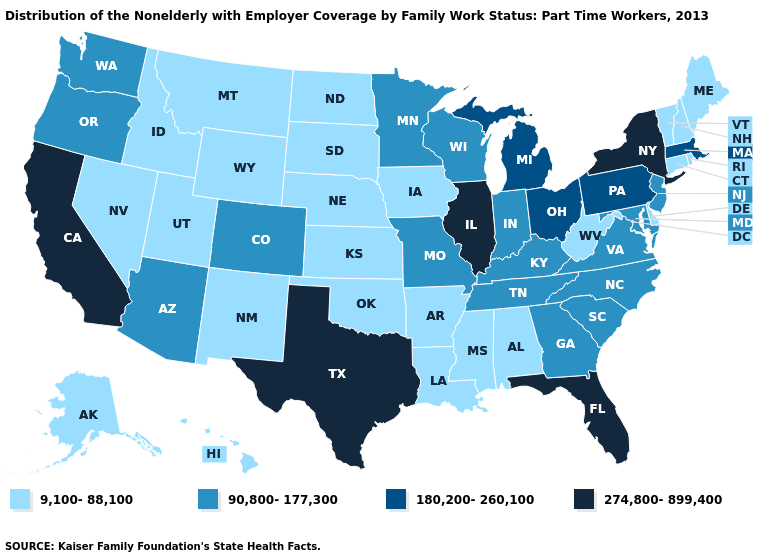Is the legend a continuous bar?
Concise answer only. No. Name the states that have a value in the range 180,200-260,100?
Short answer required. Massachusetts, Michigan, Ohio, Pennsylvania. What is the highest value in the South ?
Be succinct. 274,800-899,400. What is the value of Wyoming?
Answer briefly. 9,100-88,100. Among the states that border Oregon , which have the lowest value?
Be succinct. Idaho, Nevada. Which states have the lowest value in the West?
Answer briefly. Alaska, Hawaii, Idaho, Montana, Nevada, New Mexico, Utah, Wyoming. Is the legend a continuous bar?
Give a very brief answer. No. Does Alaska have a lower value than Michigan?
Quick response, please. Yes. What is the lowest value in the South?
Give a very brief answer. 9,100-88,100. Among the states that border Florida , which have the highest value?
Concise answer only. Georgia. What is the highest value in the MidWest ?
Answer briefly. 274,800-899,400. Does Montana have the same value as Texas?
Keep it brief. No. Which states have the lowest value in the USA?
Be succinct. Alabama, Alaska, Arkansas, Connecticut, Delaware, Hawaii, Idaho, Iowa, Kansas, Louisiana, Maine, Mississippi, Montana, Nebraska, Nevada, New Hampshire, New Mexico, North Dakota, Oklahoma, Rhode Island, South Dakota, Utah, Vermont, West Virginia, Wyoming. Does Pennsylvania have the highest value in the Northeast?
Be succinct. No. Does Nebraska have the highest value in the USA?
Short answer required. No. 